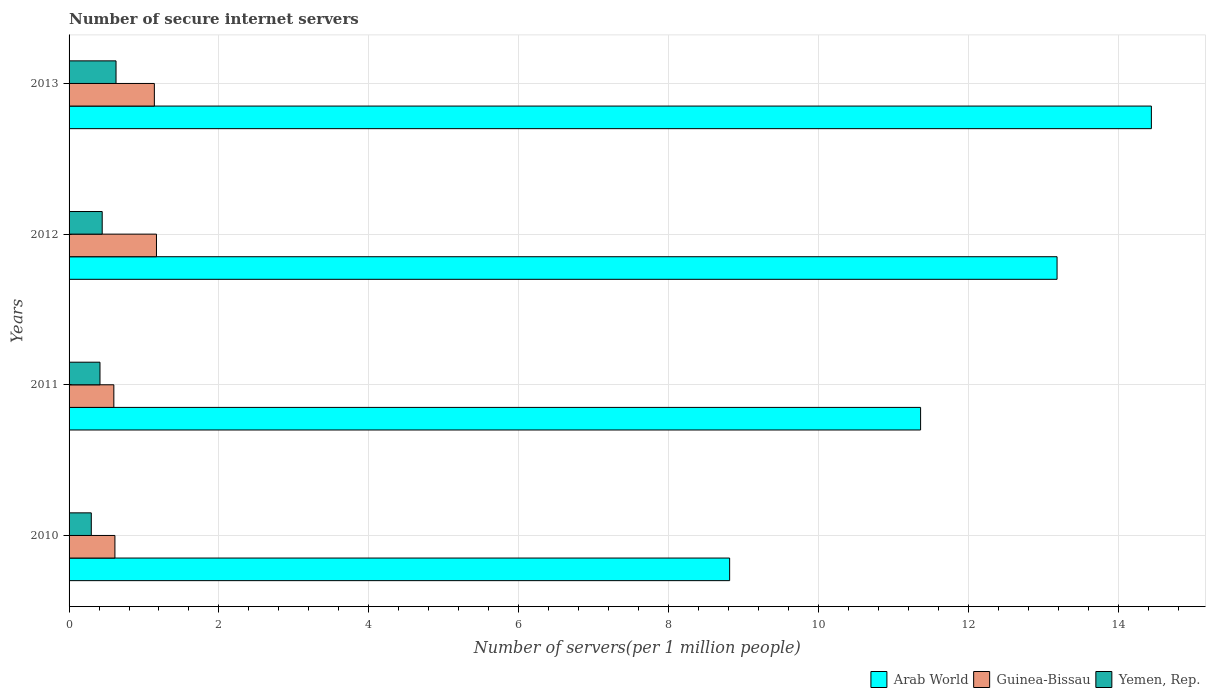How many different coloured bars are there?
Your answer should be very brief. 3. How many groups of bars are there?
Make the answer very short. 4. What is the label of the 1st group of bars from the top?
Provide a succinct answer. 2013. What is the number of secure internet servers in Guinea-Bissau in 2011?
Your answer should be compact. 0.6. Across all years, what is the maximum number of secure internet servers in Arab World?
Your answer should be very brief. 14.44. Across all years, what is the minimum number of secure internet servers in Arab World?
Your answer should be compact. 8.82. What is the total number of secure internet servers in Yemen, Rep. in the graph?
Your answer should be very brief. 1.78. What is the difference between the number of secure internet servers in Arab World in 2011 and that in 2012?
Offer a very short reply. -1.82. What is the difference between the number of secure internet servers in Guinea-Bissau in 2010 and the number of secure internet servers in Yemen, Rep. in 2013?
Your response must be concise. -0.01. What is the average number of secure internet servers in Guinea-Bissau per year?
Your answer should be compact. 0.88. In the year 2011, what is the difference between the number of secure internet servers in Yemen, Rep. and number of secure internet servers in Arab World?
Your answer should be compact. -10.95. In how many years, is the number of secure internet servers in Yemen, Rep. greater than 14 ?
Make the answer very short. 0. What is the ratio of the number of secure internet servers in Arab World in 2010 to that in 2012?
Make the answer very short. 0.67. Is the difference between the number of secure internet servers in Yemen, Rep. in 2010 and 2013 greater than the difference between the number of secure internet servers in Arab World in 2010 and 2013?
Make the answer very short. Yes. What is the difference between the highest and the second highest number of secure internet servers in Arab World?
Provide a short and direct response. 1.26. What is the difference between the highest and the lowest number of secure internet servers in Guinea-Bissau?
Ensure brevity in your answer.  0.57. In how many years, is the number of secure internet servers in Yemen, Rep. greater than the average number of secure internet servers in Yemen, Rep. taken over all years?
Provide a short and direct response. 1. Is the sum of the number of secure internet servers in Arab World in 2010 and 2012 greater than the maximum number of secure internet servers in Yemen, Rep. across all years?
Offer a very short reply. Yes. What does the 1st bar from the top in 2011 represents?
Provide a succinct answer. Yemen, Rep. What does the 3rd bar from the bottom in 2012 represents?
Provide a succinct answer. Yemen, Rep. Is it the case that in every year, the sum of the number of secure internet servers in Guinea-Bissau and number of secure internet servers in Arab World is greater than the number of secure internet servers in Yemen, Rep.?
Offer a very short reply. Yes. How many bars are there?
Make the answer very short. 12. Are all the bars in the graph horizontal?
Offer a terse response. Yes. Are the values on the major ticks of X-axis written in scientific E-notation?
Keep it short and to the point. No. Does the graph contain grids?
Your response must be concise. Yes. Where does the legend appear in the graph?
Your answer should be very brief. Bottom right. How many legend labels are there?
Your answer should be compact. 3. What is the title of the graph?
Your response must be concise. Number of secure internet servers. What is the label or title of the X-axis?
Ensure brevity in your answer.  Number of servers(per 1 million people). What is the label or title of the Y-axis?
Provide a short and direct response. Years. What is the Number of servers(per 1 million people) of Arab World in 2010?
Your answer should be very brief. 8.82. What is the Number of servers(per 1 million people) of Guinea-Bissau in 2010?
Your answer should be compact. 0.61. What is the Number of servers(per 1 million people) in Yemen, Rep. in 2010?
Provide a short and direct response. 0.3. What is the Number of servers(per 1 million people) of Arab World in 2011?
Provide a short and direct response. 11.36. What is the Number of servers(per 1 million people) of Guinea-Bissau in 2011?
Your answer should be very brief. 0.6. What is the Number of servers(per 1 million people) of Yemen, Rep. in 2011?
Ensure brevity in your answer.  0.41. What is the Number of servers(per 1 million people) of Arab World in 2012?
Ensure brevity in your answer.  13.19. What is the Number of servers(per 1 million people) of Guinea-Bissau in 2012?
Provide a succinct answer. 1.17. What is the Number of servers(per 1 million people) of Yemen, Rep. in 2012?
Provide a succinct answer. 0.44. What is the Number of servers(per 1 million people) of Arab World in 2013?
Provide a succinct answer. 14.44. What is the Number of servers(per 1 million people) in Guinea-Bissau in 2013?
Your response must be concise. 1.14. What is the Number of servers(per 1 million people) of Yemen, Rep. in 2013?
Your response must be concise. 0.63. Across all years, what is the maximum Number of servers(per 1 million people) in Arab World?
Offer a very short reply. 14.44. Across all years, what is the maximum Number of servers(per 1 million people) in Guinea-Bissau?
Provide a short and direct response. 1.17. Across all years, what is the maximum Number of servers(per 1 million people) of Yemen, Rep.?
Offer a very short reply. 0.63. Across all years, what is the minimum Number of servers(per 1 million people) in Arab World?
Provide a succinct answer. 8.82. Across all years, what is the minimum Number of servers(per 1 million people) of Guinea-Bissau?
Offer a terse response. 0.6. Across all years, what is the minimum Number of servers(per 1 million people) in Yemen, Rep.?
Make the answer very short. 0.3. What is the total Number of servers(per 1 million people) of Arab World in the graph?
Your answer should be very brief. 47.81. What is the total Number of servers(per 1 million people) in Guinea-Bissau in the graph?
Provide a succinct answer. 3.51. What is the total Number of servers(per 1 million people) of Yemen, Rep. in the graph?
Ensure brevity in your answer.  1.78. What is the difference between the Number of servers(per 1 million people) in Arab World in 2010 and that in 2011?
Make the answer very short. -2.55. What is the difference between the Number of servers(per 1 million people) of Guinea-Bissau in 2010 and that in 2011?
Keep it short and to the point. 0.01. What is the difference between the Number of servers(per 1 million people) of Yemen, Rep. in 2010 and that in 2011?
Provide a short and direct response. -0.12. What is the difference between the Number of servers(per 1 million people) in Arab World in 2010 and that in 2012?
Your answer should be very brief. -4.37. What is the difference between the Number of servers(per 1 million people) in Guinea-Bissau in 2010 and that in 2012?
Provide a succinct answer. -0.55. What is the difference between the Number of servers(per 1 million people) in Yemen, Rep. in 2010 and that in 2012?
Make the answer very short. -0.15. What is the difference between the Number of servers(per 1 million people) in Arab World in 2010 and that in 2013?
Provide a short and direct response. -5.63. What is the difference between the Number of servers(per 1 million people) in Guinea-Bissau in 2010 and that in 2013?
Keep it short and to the point. -0.53. What is the difference between the Number of servers(per 1 million people) in Yemen, Rep. in 2010 and that in 2013?
Offer a very short reply. -0.33. What is the difference between the Number of servers(per 1 million people) of Arab World in 2011 and that in 2012?
Offer a very short reply. -1.82. What is the difference between the Number of servers(per 1 million people) in Guinea-Bissau in 2011 and that in 2012?
Offer a very short reply. -0.57. What is the difference between the Number of servers(per 1 million people) in Yemen, Rep. in 2011 and that in 2012?
Offer a very short reply. -0.03. What is the difference between the Number of servers(per 1 million people) of Arab World in 2011 and that in 2013?
Keep it short and to the point. -3.08. What is the difference between the Number of servers(per 1 million people) in Guinea-Bissau in 2011 and that in 2013?
Provide a short and direct response. -0.54. What is the difference between the Number of servers(per 1 million people) of Yemen, Rep. in 2011 and that in 2013?
Keep it short and to the point. -0.21. What is the difference between the Number of servers(per 1 million people) in Arab World in 2012 and that in 2013?
Make the answer very short. -1.26. What is the difference between the Number of servers(per 1 million people) of Guinea-Bissau in 2012 and that in 2013?
Provide a succinct answer. 0.03. What is the difference between the Number of servers(per 1 million people) in Yemen, Rep. in 2012 and that in 2013?
Keep it short and to the point. -0.18. What is the difference between the Number of servers(per 1 million people) of Arab World in 2010 and the Number of servers(per 1 million people) of Guinea-Bissau in 2011?
Your answer should be compact. 8.22. What is the difference between the Number of servers(per 1 million people) of Arab World in 2010 and the Number of servers(per 1 million people) of Yemen, Rep. in 2011?
Offer a terse response. 8.4. What is the difference between the Number of servers(per 1 million people) of Guinea-Bissau in 2010 and the Number of servers(per 1 million people) of Yemen, Rep. in 2011?
Give a very brief answer. 0.2. What is the difference between the Number of servers(per 1 million people) of Arab World in 2010 and the Number of servers(per 1 million people) of Guinea-Bissau in 2012?
Your answer should be very brief. 7.65. What is the difference between the Number of servers(per 1 million people) in Arab World in 2010 and the Number of servers(per 1 million people) in Yemen, Rep. in 2012?
Offer a terse response. 8.37. What is the difference between the Number of servers(per 1 million people) in Guinea-Bissau in 2010 and the Number of servers(per 1 million people) in Yemen, Rep. in 2012?
Your response must be concise. 0.17. What is the difference between the Number of servers(per 1 million people) in Arab World in 2010 and the Number of servers(per 1 million people) in Guinea-Bissau in 2013?
Keep it short and to the point. 7.68. What is the difference between the Number of servers(per 1 million people) of Arab World in 2010 and the Number of servers(per 1 million people) of Yemen, Rep. in 2013?
Make the answer very short. 8.19. What is the difference between the Number of servers(per 1 million people) in Guinea-Bissau in 2010 and the Number of servers(per 1 million people) in Yemen, Rep. in 2013?
Make the answer very short. -0.01. What is the difference between the Number of servers(per 1 million people) of Arab World in 2011 and the Number of servers(per 1 million people) of Guinea-Bissau in 2012?
Your response must be concise. 10.2. What is the difference between the Number of servers(per 1 million people) in Arab World in 2011 and the Number of servers(per 1 million people) in Yemen, Rep. in 2012?
Make the answer very short. 10.92. What is the difference between the Number of servers(per 1 million people) in Guinea-Bissau in 2011 and the Number of servers(per 1 million people) in Yemen, Rep. in 2012?
Give a very brief answer. 0.16. What is the difference between the Number of servers(per 1 million people) of Arab World in 2011 and the Number of servers(per 1 million people) of Guinea-Bissau in 2013?
Offer a very short reply. 10.23. What is the difference between the Number of servers(per 1 million people) of Arab World in 2011 and the Number of servers(per 1 million people) of Yemen, Rep. in 2013?
Make the answer very short. 10.74. What is the difference between the Number of servers(per 1 million people) of Guinea-Bissau in 2011 and the Number of servers(per 1 million people) of Yemen, Rep. in 2013?
Give a very brief answer. -0.03. What is the difference between the Number of servers(per 1 million people) of Arab World in 2012 and the Number of servers(per 1 million people) of Guinea-Bissau in 2013?
Provide a short and direct response. 12.05. What is the difference between the Number of servers(per 1 million people) in Arab World in 2012 and the Number of servers(per 1 million people) in Yemen, Rep. in 2013?
Ensure brevity in your answer.  12.56. What is the difference between the Number of servers(per 1 million people) of Guinea-Bissau in 2012 and the Number of servers(per 1 million people) of Yemen, Rep. in 2013?
Your answer should be very brief. 0.54. What is the average Number of servers(per 1 million people) in Arab World per year?
Offer a very short reply. 11.95. What is the average Number of servers(per 1 million people) of Guinea-Bissau per year?
Provide a succinct answer. 0.88. What is the average Number of servers(per 1 million people) of Yemen, Rep. per year?
Your answer should be compact. 0.44. In the year 2010, what is the difference between the Number of servers(per 1 million people) in Arab World and Number of servers(per 1 million people) in Guinea-Bissau?
Provide a short and direct response. 8.2. In the year 2010, what is the difference between the Number of servers(per 1 million people) of Arab World and Number of servers(per 1 million people) of Yemen, Rep.?
Ensure brevity in your answer.  8.52. In the year 2010, what is the difference between the Number of servers(per 1 million people) in Guinea-Bissau and Number of servers(per 1 million people) in Yemen, Rep.?
Your answer should be very brief. 0.32. In the year 2011, what is the difference between the Number of servers(per 1 million people) of Arab World and Number of servers(per 1 million people) of Guinea-Bissau?
Give a very brief answer. 10.77. In the year 2011, what is the difference between the Number of servers(per 1 million people) of Arab World and Number of servers(per 1 million people) of Yemen, Rep.?
Your answer should be compact. 10.95. In the year 2011, what is the difference between the Number of servers(per 1 million people) in Guinea-Bissau and Number of servers(per 1 million people) in Yemen, Rep.?
Your answer should be very brief. 0.18. In the year 2012, what is the difference between the Number of servers(per 1 million people) in Arab World and Number of servers(per 1 million people) in Guinea-Bissau?
Give a very brief answer. 12.02. In the year 2012, what is the difference between the Number of servers(per 1 million people) of Arab World and Number of servers(per 1 million people) of Yemen, Rep.?
Give a very brief answer. 12.74. In the year 2012, what is the difference between the Number of servers(per 1 million people) of Guinea-Bissau and Number of servers(per 1 million people) of Yemen, Rep.?
Ensure brevity in your answer.  0.72. In the year 2013, what is the difference between the Number of servers(per 1 million people) in Arab World and Number of servers(per 1 million people) in Guinea-Bissau?
Ensure brevity in your answer.  13.31. In the year 2013, what is the difference between the Number of servers(per 1 million people) of Arab World and Number of servers(per 1 million people) of Yemen, Rep.?
Give a very brief answer. 13.82. In the year 2013, what is the difference between the Number of servers(per 1 million people) in Guinea-Bissau and Number of servers(per 1 million people) in Yemen, Rep.?
Make the answer very short. 0.51. What is the ratio of the Number of servers(per 1 million people) in Arab World in 2010 to that in 2011?
Keep it short and to the point. 0.78. What is the ratio of the Number of servers(per 1 million people) in Guinea-Bissau in 2010 to that in 2011?
Your answer should be very brief. 1.02. What is the ratio of the Number of servers(per 1 million people) in Yemen, Rep. in 2010 to that in 2011?
Your answer should be very brief. 0.72. What is the ratio of the Number of servers(per 1 million people) of Arab World in 2010 to that in 2012?
Offer a very short reply. 0.67. What is the ratio of the Number of servers(per 1 million people) in Guinea-Bissau in 2010 to that in 2012?
Offer a very short reply. 0.52. What is the ratio of the Number of servers(per 1 million people) of Yemen, Rep. in 2010 to that in 2012?
Make the answer very short. 0.67. What is the ratio of the Number of servers(per 1 million people) of Arab World in 2010 to that in 2013?
Ensure brevity in your answer.  0.61. What is the ratio of the Number of servers(per 1 million people) of Guinea-Bissau in 2010 to that in 2013?
Keep it short and to the point. 0.54. What is the ratio of the Number of servers(per 1 million people) in Yemen, Rep. in 2010 to that in 2013?
Offer a terse response. 0.47. What is the ratio of the Number of servers(per 1 million people) of Arab World in 2011 to that in 2012?
Give a very brief answer. 0.86. What is the ratio of the Number of servers(per 1 million people) of Guinea-Bissau in 2011 to that in 2012?
Make the answer very short. 0.51. What is the ratio of the Number of servers(per 1 million people) of Yemen, Rep. in 2011 to that in 2012?
Provide a succinct answer. 0.93. What is the ratio of the Number of servers(per 1 million people) in Arab World in 2011 to that in 2013?
Give a very brief answer. 0.79. What is the ratio of the Number of servers(per 1 million people) of Guinea-Bissau in 2011 to that in 2013?
Offer a very short reply. 0.53. What is the ratio of the Number of servers(per 1 million people) in Yemen, Rep. in 2011 to that in 2013?
Give a very brief answer. 0.66. What is the ratio of the Number of servers(per 1 million people) of Arab World in 2012 to that in 2013?
Your response must be concise. 0.91. What is the ratio of the Number of servers(per 1 million people) in Guinea-Bissau in 2012 to that in 2013?
Your answer should be very brief. 1.02. What is the ratio of the Number of servers(per 1 million people) of Yemen, Rep. in 2012 to that in 2013?
Provide a short and direct response. 0.71. What is the difference between the highest and the second highest Number of servers(per 1 million people) of Arab World?
Provide a succinct answer. 1.26. What is the difference between the highest and the second highest Number of servers(per 1 million people) in Guinea-Bissau?
Offer a terse response. 0.03. What is the difference between the highest and the second highest Number of servers(per 1 million people) of Yemen, Rep.?
Make the answer very short. 0.18. What is the difference between the highest and the lowest Number of servers(per 1 million people) of Arab World?
Give a very brief answer. 5.63. What is the difference between the highest and the lowest Number of servers(per 1 million people) in Guinea-Bissau?
Offer a very short reply. 0.57. What is the difference between the highest and the lowest Number of servers(per 1 million people) of Yemen, Rep.?
Make the answer very short. 0.33. 